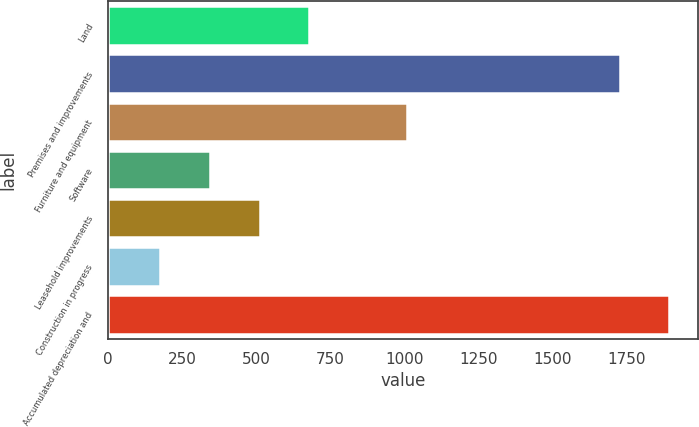<chart> <loc_0><loc_0><loc_500><loc_500><bar_chart><fcel>Land<fcel>Premises and improvements<fcel>Furniture and equipment<fcel>Software<fcel>Leasehold improvements<fcel>Construction in progress<fcel>Accumulated depreciation and<nl><fcel>679.6<fcel>1727<fcel>1010<fcel>343.2<fcel>511.4<fcel>175<fcel>1895.2<nl></chart> 